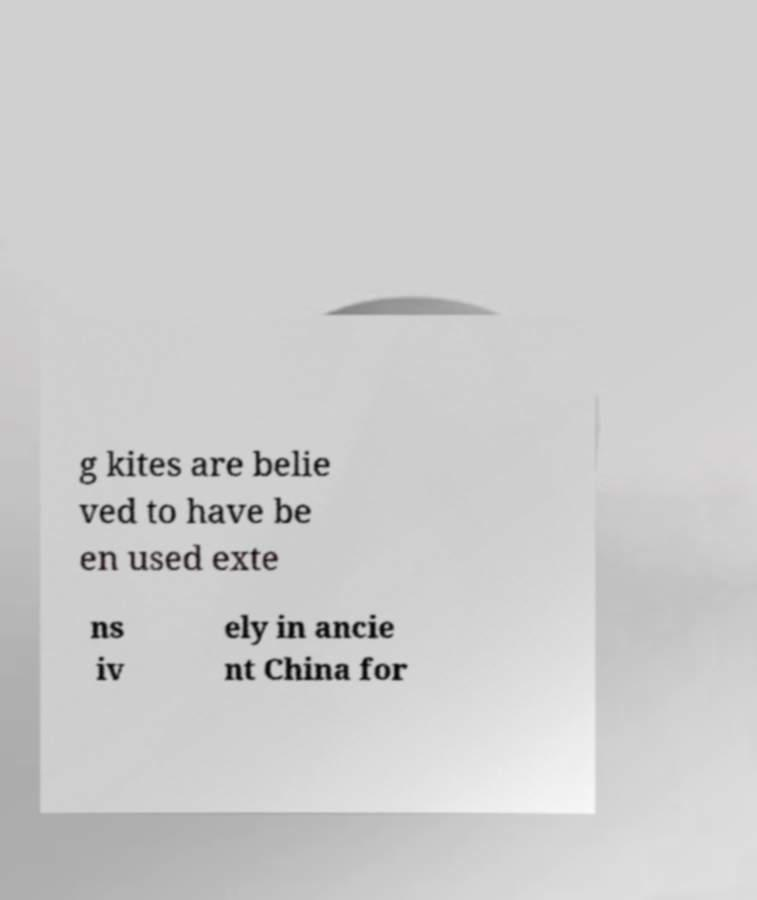Please identify and transcribe the text found in this image. g kites are belie ved to have be en used exte ns iv ely in ancie nt China for 